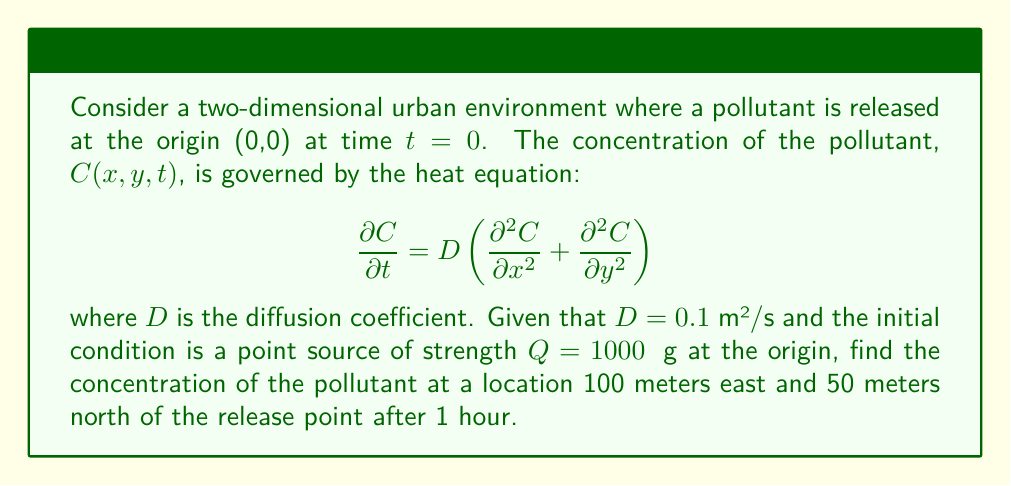Can you answer this question? To solve this problem, we'll use the fundamental solution of the two-dimensional heat equation for an instantaneous point source:

$$C(x,y,t) = \frac{Q}{4\pi Dt} \exp\left(-\frac{x^2 + y^2}{4Dt}\right)$$

Step 1: Identify the given parameters:
- D = 0.1 m²/s
- Q = 1000 μg
- x = 100 m (east)
- y = 50 m (north)
- t = 1 hour = 3600 s

Step 2: Substitute these values into the equation:

$$C(100, 50, 3600) = \frac{1000}{4\pi \cdot 0.1 \cdot 3600} \exp\left(-\frac{100^2 + 50^2}{4 \cdot 0.1 \cdot 3600}\right)$$

Step 3: Simplify the expression:

$$C(100, 50, 3600) = \frac{1000}{452.39} \exp\left(-\frac{12500}{144}\right)$$

Step 4: Calculate the result:

$$C(100, 50, 3600) = 2.21 \cdot \exp(-86.81) = 2.21 \cdot 1.70 \times 10^{-38} = 3.76 \times 10^{-38} \text{ μg/m²}$$

Therefore, the concentration of the pollutant at the specified location after 1 hour is approximately 3.76 × 10^-38 μg/m².
Answer: $3.76 \times 10^{-38} \text{ μg/m²}$ 